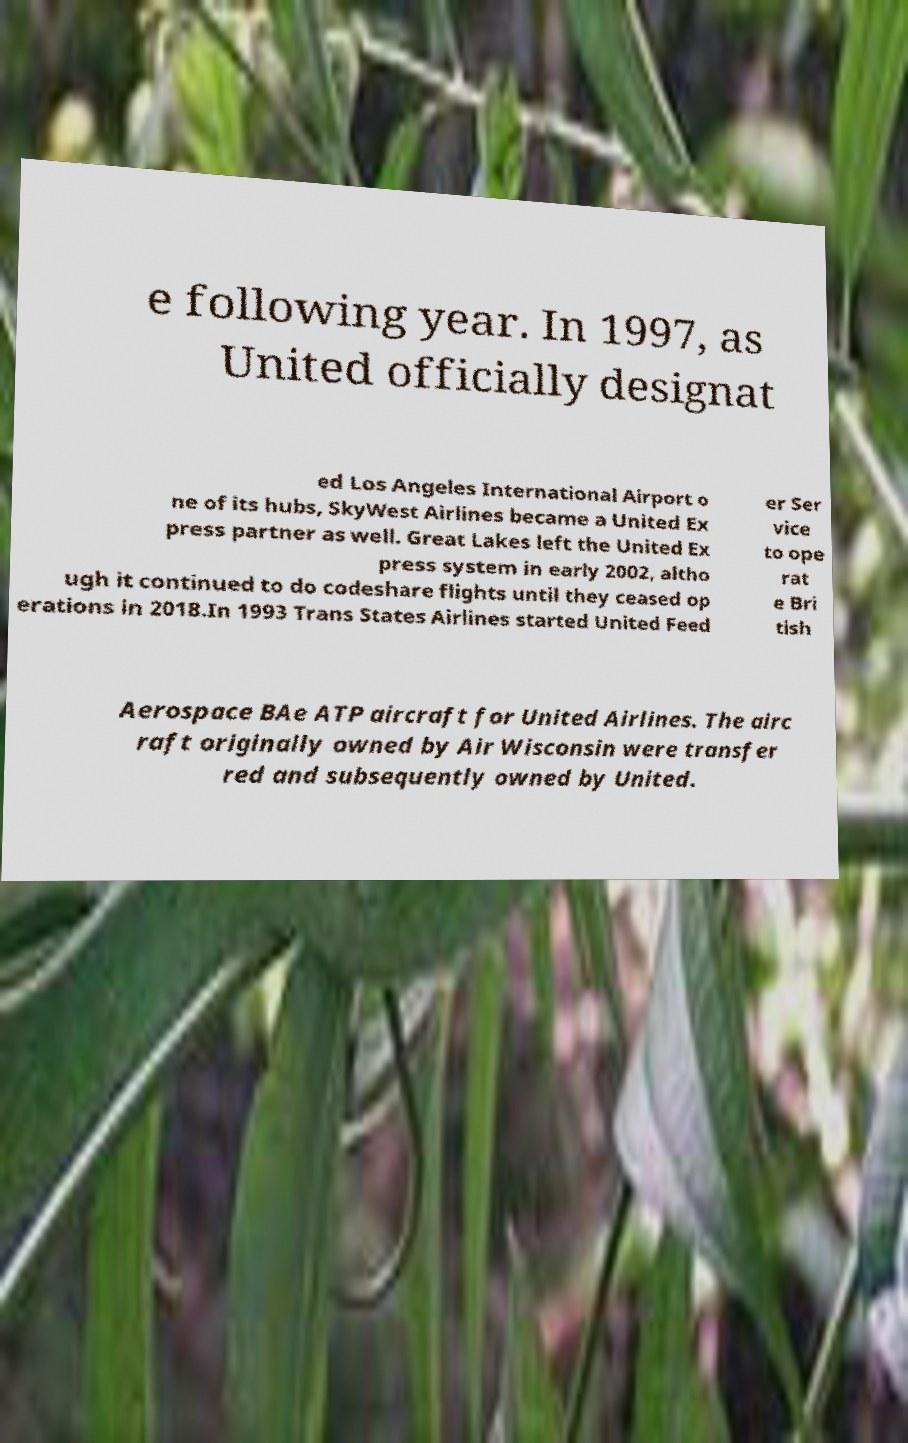Please identify and transcribe the text found in this image. e following year. In 1997, as United officially designat ed Los Angeles International Airport o ne of its hubs, SkyWest Airlines became a United Ex press partner as well. Great Lakes left the United Ex press system in early 2002, altho ugh it continued to do codeshare flights until they ceased op erations in 2018.In 1993 Trans States Airlines started United Feed er Ser vice to ope rat e Bri tish Aerospace BAe ATP aircraft for United Airlines. The airc raft originally owned by Air Wisconsin were transfer red and subsequently owned by United. 